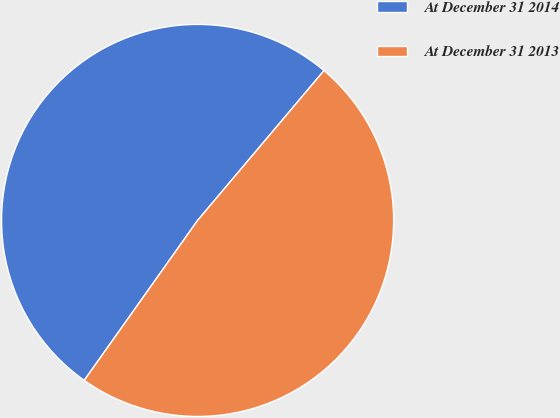<chart> <loc_0><loc_0><loc_500><loc_500><pie_chart><fcel>At December 31 2014<fcel>At December 31 2013<nl><fcel>51.34%<fcel>48.66%<nl></chart> 